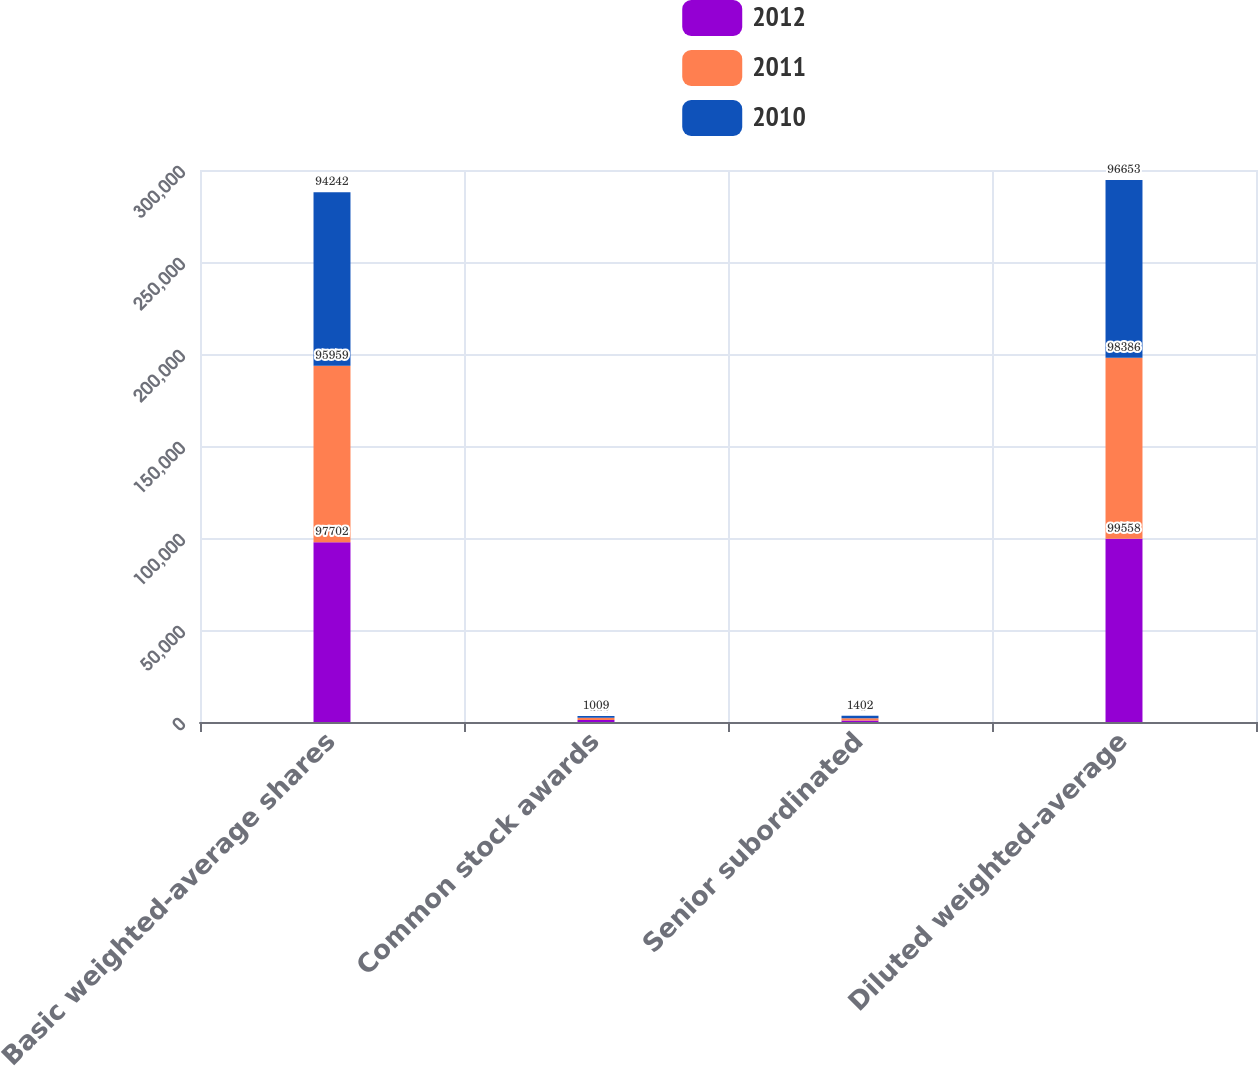Convert chart. <chart><loc_0><loc_0><loc_500><loc_500><stacked_bar_chart><ecel><fcel>Basic weighted-average shares<fcel>Common stock awards<fcel>Senior subordinated<fcel>Diluted weighted-average<nl><fcel>2012<fcel>97702<fcel>1040<fcel>816<fcel>99558<nl><fcel>2011<fcel>95959<fcel>1213<fcel>1214<fcel>98386<nl><fcel>2010<fcel>94242<fcel>1009<fcel>1402<fcel>96653<nl></chart> 